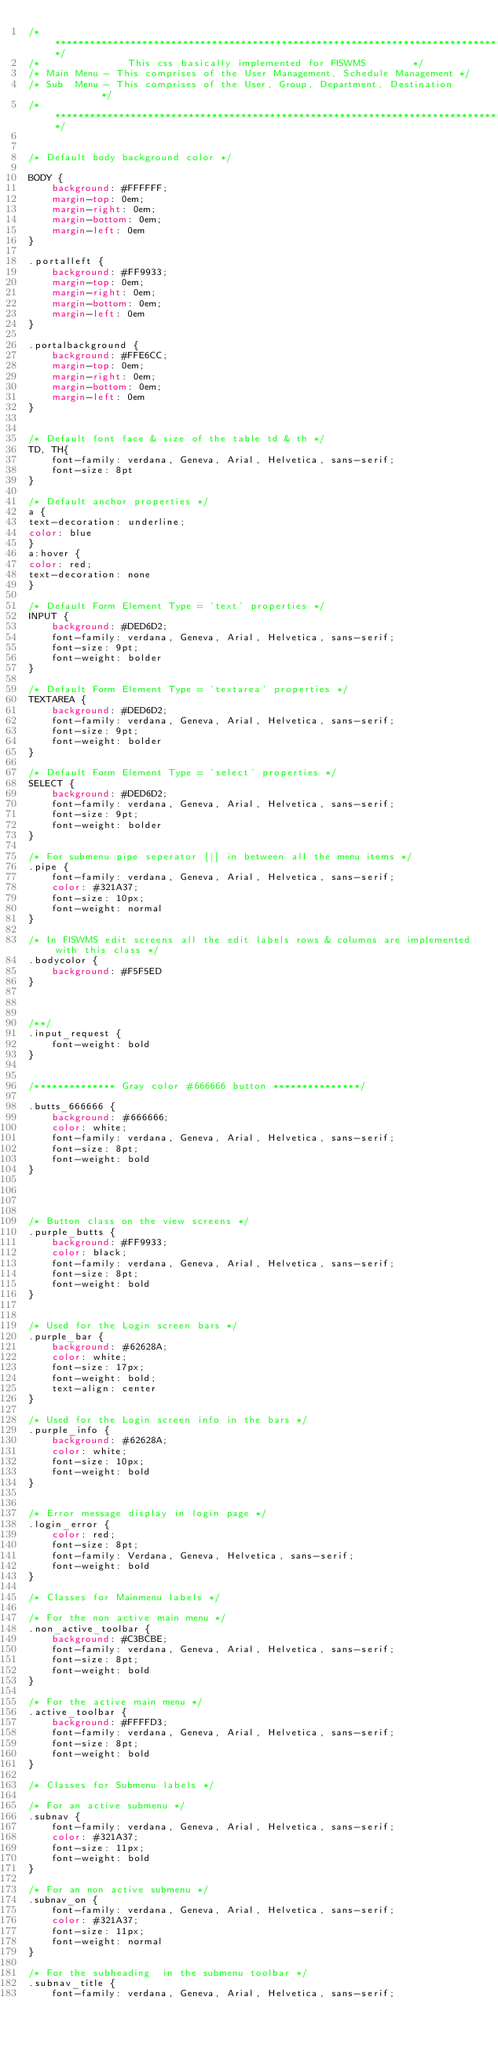<code> <loc_0><loc_0><loc_500><loc_500><_CSS_>/***************************************************************************************/
/* 	             This css basically implemented for FISWMS 		  */
/* Main Menu - This comprises of the User Management, Schedule Management */
/* Sub  Menu - This comprises of the User, Group, Department, Destination         */
/****************************************************************************************/


/* Default body background color */

BODY {
	background: #FFFFFF;
    margin-top: 0em;
    margin-right: 0em;
    margin-bottom: 0em;
    margin-left: 0em 
}

.portalleft {
	background: #FF9933;
    margin-top: 0em;
    margin-right: 0em;
    margin-bottom: 0em;
    margin-left: 0em 
}

.portalbackground {
	background: #FFE6CC;
    margin-top: 0em;
    margin-right: 0em;
    margin-bottom: 0em;
    margin-left: 0em 
}


/* Default font face & size of the table td & th */
TD, TH{
	font-family: verdana, Geneva, Arial, Helvetica, sans-serif;
	font-size: 8pt
}

/* Default anchor properties */
a {
text-decoration: underline; 
color: blue
}
a:hover {
color: red; 
text-decoration: none
}

/* Default Form Element Type = 'text' properties */
INPUT {
	background: #DED6D2;
	font-family: verdana, Geneva, Arial, Helvetica, sans-serif;
	font-size: 9pt;
	font-weight: bolder
}

/* Default Form Element Type = 'textarea' properties */
TEXTAREA {
	background: #DED6D2;
	font-family: verdana, Geneva, Arial, Helvetica, sans-serif;
	font-size: 9pt;
	font-weight: bolder
}

/* Default Form Element Type = 'select' properties */
SELECT {
	background: #DED6D2;
	font-family: verdana, Geneva, Arial, Helvetica, sans-serif;
	font-size: 9pt;
	font-weight: bolder
}

/* For submenu pipe seperator [|] in between all the menu items */
.pipe {
	font-family: verdana, Geneva, Arial, Helvetica, sans-serif;
	color: #321A37;
	font-size: 10px;
	font-weight: normal
}

/* In FISWMS edit screens all the edit labels rows & columns are implemented with this class */
.bodycolor {
	background: #F5F5ED
}



/**/
.input_request {
	font-weight: bold
}


/************** Gray color #666666 button ***************/

.butts_666666 {
	background: #666666;
	color: white;
	font-family: verdana, Geneva, Arial, Helvetica, sans-serif;
	font-size: 8pt;
	font-weight: bold
}




/* Button class on the view screens */
.purple_butts {
	background: #FF9933;
	color: black;
	font-family: verdana, Geneva, Arial, Helvetica, sans-serif;
	font-size: 8pt;
	font-weight: bold
}


/* Used for the Login screen bars */
.purple_bar {
	background: #62628A;
	color: white;
	font-size: 17px;
	font-weight: bold;
	text-align: center
}

/* Used for the Login screen info in the bars */
.purple_info {
	background: #62628A;
	color: white;
	font-size: 10px;
	font-weight: bold
}


/* Error message display in login page */
.login_error {
	color: red; 
	font-size: 8pt; 
	font-family: Verdana, Geneva, Helvetica, sans-serif; 
	font-weight: bold
}

/* Classes for Mainmenu labels */

/* For the non active main menu */
.non_active_toolbar {
	background: #C3BCBE;
	font-family: verdana, Geneva, Arial, Helvetica, sans-serif;
	font-size: 8pt;
	font-weight: bold
}

/* For the active main menu */
.active_toolbar {
	background: #FFFFD3;
	font-family: verdana, Geneva, Arial, Helvetica, sans-serif;
	font-size: 8pt;
	font-weight: bold
}

/* Classes for Submenu labels */

/* For an active submenu */
.subnav {
	font-family: verdana, Geneva, Arial, Helvetica, sans-serif;
	color: #321A37;
	font-size: 11px;
	font-weight: bold
}

/* For an non active submenu */
.subnav_on {
	font-family: verdana, Geneva, Arial, Helvetica, sans-serif;
	color: #321A37;
	font-size: 11px;
	font-weight: normal
}

/* For the subheading  in the submenu toolbar */
.subnav_title {
	font-family: verdana, Geneva, Arial, Helvetica, sans-serif;</code> 